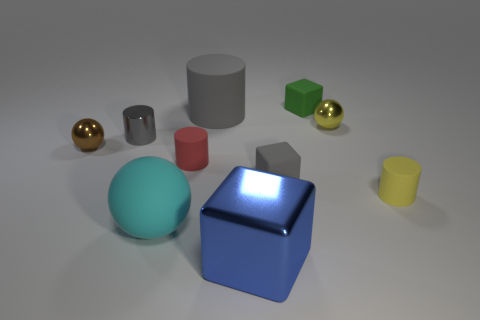Subtract all gray matte cylinders. How many cylinders are left? 3 Subtract all cyan balls. How many balls are left? 2 Subtract all balls. How many objects are left? 7 Subtract 1 blocks. How many blocks are left? 2 Subtract all cyan cylinders. How many red cubes are left? 0 Subtract all cylinders. Subtract all small brown spheres. How many objects are left? 5 Add 3 small gray metal objects. How many small gray metal objects are left? 4 Add 6 blue metal things. How many blue metal things exist? 7 Subtract 1 green cubes. How many objects are left? 9 Subtract all blue cylinders. Subtract all cyan spheres. How many cylinders are left? 4 